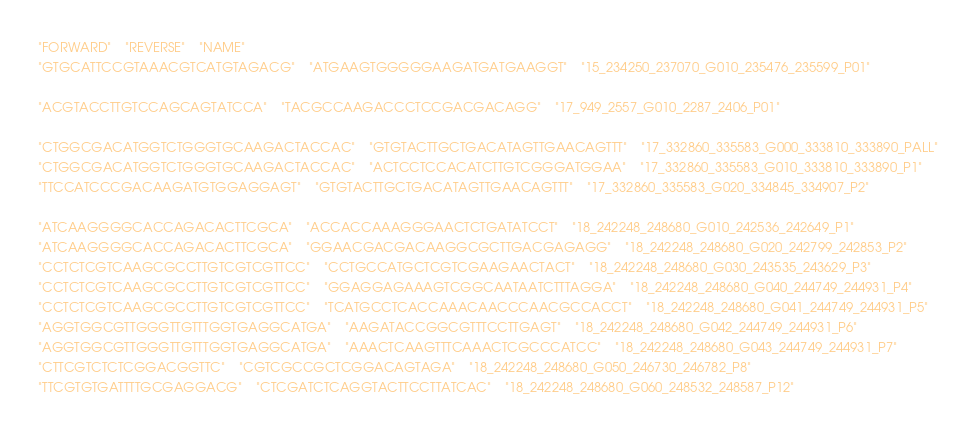Convert code to text. <code><loc_0><loc_0><loc_500><loc_500><_SQL_>"FORWARD"	"REVERSE"	"NAME"
"GTGCATTCCGTAAACGTCATGTAGACG"	"ATGAAGTGGGGGAAGATGATGAAGGT"	"15_234250_237070_G010_235476_235599_P01"
		
"ACGTACCTTGTCCAGCAGTATCCA"	"TACGCCAAGACCCTCCGACGACAGG"	"17_949_2557_G010_2287_2406_P01"
		
"CTGGCGACATGGTCTGGGTGCAAGACTACCAC"	"GTGTACTTGCTGACATAGTTGAACAGTTT"	"17_332860_335583_G000_333810_333890_PALL"
"CTGGCGACATGGTCTGGGTGCAAGACTACCAC"	"ACTCCTCCACATCTTGTCGGGATGGAA"	"17_332860_335583_G010_333810_333890_P1"
"TTCCATCCCGACAAGATGTGGAGGAGT"	"GTGTACTTGCTGACATAGTTGAACAGTTT"	"17_332860_335583_G020_334845_334907_P2"
		
"ATCAAGGGGCACCAGACACTTCGCA"	"ACCACCAAAGGGAACTCTGATATCCT"	"18_242248_248680_G010_242536_242649_P1"
"ATCAAGGGGCACCAGACACTTCGCA"	"GGAACGACGACAAGGCGCTTGACGAGAGG"	"18_242248_248680_G020_242799_242853_P2"
"CCTCTCGTCAAGCGCCTTGTCGTCGTTCC"	"CCTGCCATGCTCGTCGAAGAACTACT"	"18_242248_248680_G030_243535_243629_P3"
"CCTCTCGTCAAGCGCCTTGTCGTCGTTCC"	"GGAGGAGAAAGTCGGCAATAATCTTTAGGA"	"18_242248_248680_G040_244749_244931_P4"
"CCTCTCGTCAAGCGCCTTGTCGTCGTTCC"	"TCATGCCTCACCAAACAACCCAACGCCACCT"	"18_242248_248680_G041_244749_244931_P5"
"AGGTGGCGTTGGGTTGTTTGGTGAGGCATGA"	"AAGATACCGGCGTTTCCTTGAGT"	"18_242248_248680_G042_244749_244931_P6"
"AGGTGGCGTTGGGTTGTTTGGTGAGGCATGA"	"AAACTCAAGTTTCAAACTCGCCCATCC"	"18_242248_248680_G043_244749_244931_P7"
"CTTCGTCTCTCGGACGGTTC"	"CGTCGCCGCTCGGACAGTAGA"	"18_242248_248680_G050_246730_246782_P8"
"TTCGTGTGATTTTGCGAGGACG"	"CTCGATCTCAGGTACTTCCTTATCAC"	"18_242248_248680_G060_248532_248587_P12"
</code> 